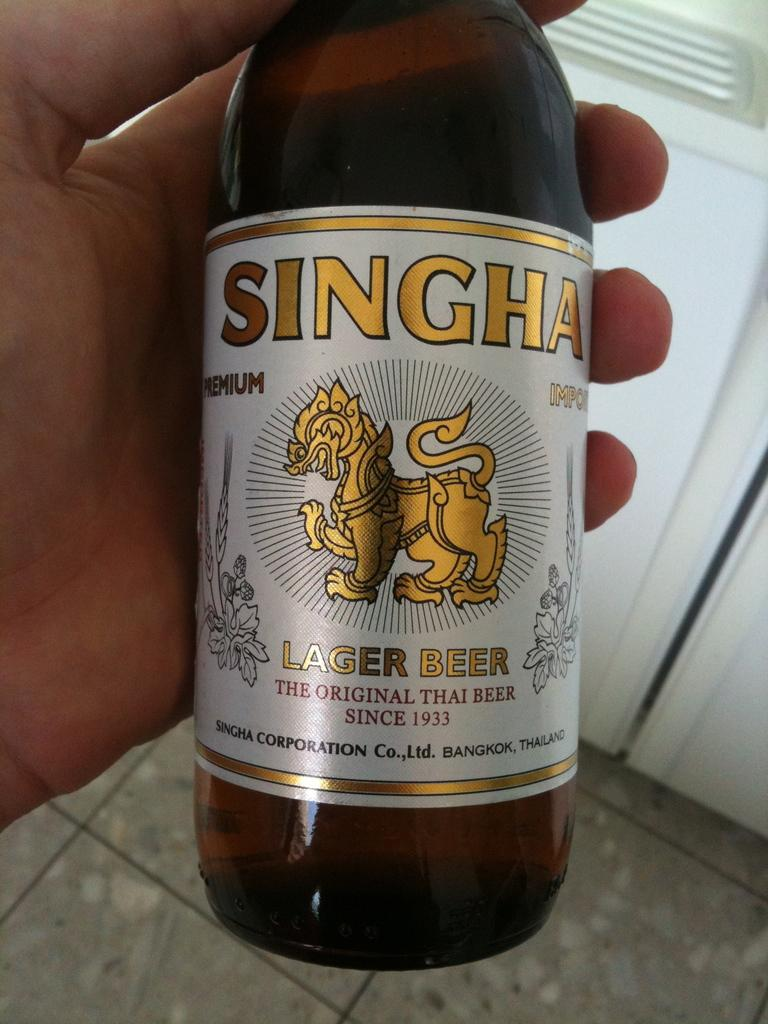<image>
Render a clear and concise summary of the photo. A hand holds a bottle of Singha Lager Beer, The Original Thai Beer since 1933. 